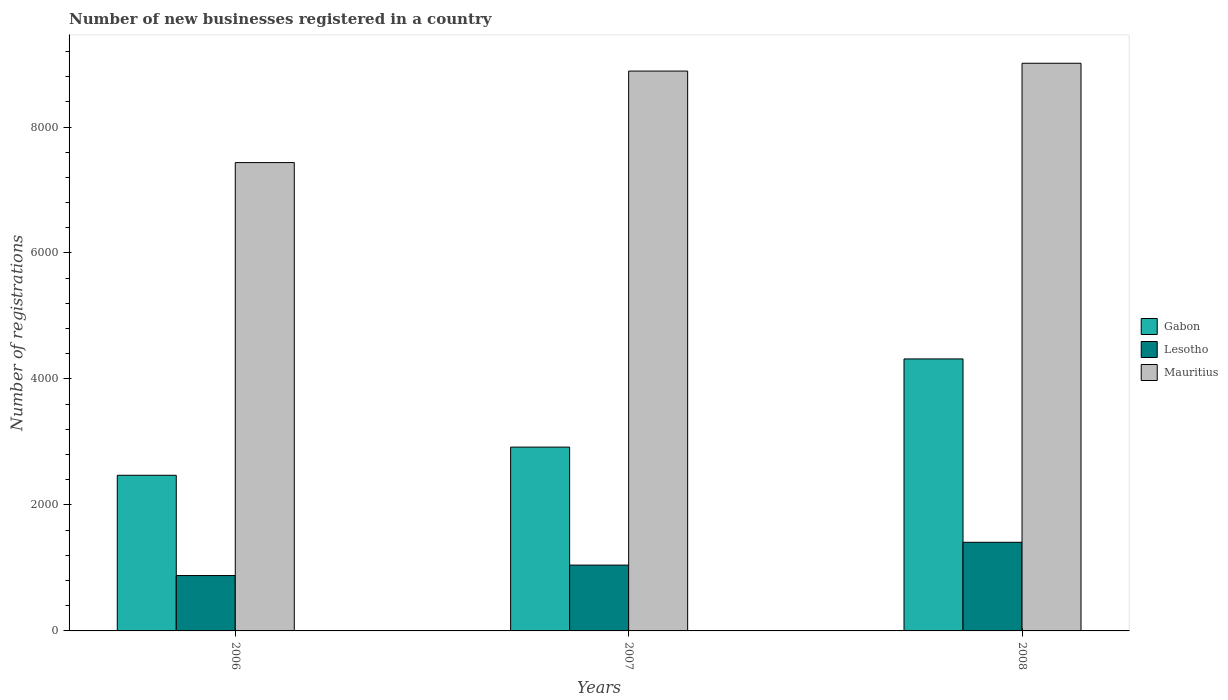How many groups of bars are there?
Keep it short and to the point. 3. How many bars are there on the 2nd tick from the left?
Offer a very short reply. 3. What is the label of the 2nd group of bars from the left?
Your answer should be very brief. 2007. What is the number of new businesses registered in Lesotho in 2008?
Your answer should be compact. 1407. Across all years, what is the maximum number of new businesses registered in Gabon?
Make the answer very short. 4318. Across all years, what is the minimum number of new businesses registered in Gabon?
Provide a short and direct response. 2471. In which year was the number of new businesses registered in Mauritius maximum?
Ensure brevity in your answer.  2008. In which year was the number of new businesses registered in Gabon minimum?
Ensure brevity in your answer.  2006. What is the total number of new businesses registered in Lesotho in the graph?
Offer a very short reply. 3331. What is the difference between the number of new businesses registered in Gabon in 2007 and that in 2008?
Offer a very short reply. -1400. What is the difference between the number of new businesses registered in Gabon in 2007 and the number of new businesses registered in Mauritius in 2008?
Your answer should be compact. -6094. What is the average number of new businesses registered in Gabon per year?
Your response must be concise. 3235.67. In the year 2007, what is the difference between the number of new businesses registered in Gabon and number of new businesses registered in Mauritius?
Keep it short and to the point. -5970. What is the ratio of the number of new businesses registered in Mauritius in 2006 to that in 2008?
Offer a very short reply. 0.83. What is the difference between the highest and the second highest number of new businesses registered in Mauritius?
Offer a terse response. 124. What is the difference between the highest and the lowest number of new businesses registered in Lesotho?
Give a very brief answer. 528. What does the 2nd bar from the left in 2008 represents?
Your response must be concise. Lesotho. What does the 2nd bar from the right in 2008 represents?
Provide a succinct answer. Lesotho. Is it the case that in every year, the sum of the number of new businesses registered in Lesotho and number of new businesses registered in Mauritius is greater than the number of new businesses registered in Gabon?
Your answer should be compact. Yes. Are the values on the major ticks of Y-axis written in scientific E-notation?
Make the answer very short. No. Does the graph contain any zero values?
Ensure brevity in your answer.  No. Does the graph contain grids?
Your answer should be compact. No. Where does the legend appear in the graph?
Offer a terse response. Center right. How are the legend labels stacked?
Keep it short and to the point. Vertical. What is the title of the graph?
Your answer should be compact. Number of new businesses registered in a country. Does "Vanuatu" appear as one of the legend labels in the graph?
Offer a very short reply. No. What is the label or title of the X-axis?
Provide a short and direct response. Years. What is the label or title of the Y-axis?
Ensure brevity in your answer.  Number of registrations. What is the Number of registrations in Gabon in 2006?
Make the answer very short. 2471. What is the Number of registrations in Lesotho in 2006?
Keep it short and to the point. 879. What is the Number of registrations of Mauritius in 2006?
Ensure brevity in your answer.  7435. What is the Number of registrations of Gabon in 2007?
Ensure brevity in your answer.  2918. What is the Number of registrations in Lesotho in 2007?
Your response must be concise. 1045. What is the Number of registrations of Mauritius in 2007?
Make the answer very short. 8888. What is the Number of registrations of Gabon in 2008?
Provide a succinct answer. 4318. What is the Number of registrations of Lesotho in 2008?
Give a very brief answer. 1407. What is the Number of registrations of Mauritius in 2008?
Your response must be concise. 9012. Across all years, what is the maximum Number of registrations of Gabon?
Ensure brevity in your answer.  4318. Across all years, what is the maximum Number of registrations of Lesotho?
Provide a short and direct response. 1407. Across all years, what is the maximum Number of registrations in Mauritius?
Your answer should be very brief. 9012. Across all years, what is the minimum Number of registrations of Gabon?
Ensure brevity in your answer.  2471. Across all years, what is the minimum Number of registrations in Lesotho?
Keep it short and to the point. 879. Across all years, what is the minimum Number of registrations of Mauritius?
Offer a terse response. 7435. What is the total Number of registrations of Gabon in the graph?
Offer a very short reply. 9707. What is the total Number of registrations in Lesotho in the graph?
Offer a terse response. 3331. What is the total Number of registrations in Mauritius in the graph?
Offer a terse response. 2.53e+04. What is the difference between the Number of registrations of Gabon in 2006 and that in 2007?
Offer a very short reply. -447. What is the difference between the Number of registrations in Lesotho in 2006 and that in 2007?
Give a very brief answer. -166. What is the difference between the Number of registrations in Mauritius in 2006 and that in 2007?
Offer a terse response. -1453. What is the difference between the Number of registrations in Gabon in 2006 and that in 2008?
Keep it short and to the point. -1847. What is the difference between the Number of registrations in Lesotho in 2006 and that in 2008?
Give a very brief answer. -528. What is the difference between the Number of registrations in Mauritius in 2006 and that in 2008?
Provide a short and direct response. -1577. What is the difference between the Number of registrations of Gabon in 2007 and that in 2008?
Keep it short and to the point. -1400. What is the difference between the Number of registrations in Lesotho in 2007 and that in 2008?
Offer a terse response. -362. What is the difference between the Number of registrations of Mauritius in 2007 and that in 2008?
Ensure brevity in your answer.  -124. What is the difference between the Number of registrations in Gabon in 2006 and the Number of registrations in Lesotho in 2007?
Offer a very short reply. 1426. What is the difference between the Number of registrations of Gabon in 2006 and the Number of registrations of Mauritius in 2007?
Make the answer very short. -6417. What is the difference between the Number of registrations in Lesotho in 2006 and the Number of registrations in Mauritius in 2007?
Your response must be concise. -8009. What is the difference between the Number of registrations in Gabon in 2006 and the Number of registrations in Lesotho in 2008?
Offer a very short reply. 1064. What is the difference between the Number of registrations of Gabon in 2006 and the Number of registrations of Mauritius in 2008?
Ensure brevity in your answer.  -6541. What is the difference between the Number of registrations of Lesotho in 2006 and the Number of registrations of Mauritius in 2008?
Make the answer very short. -8133. What is the difference between the Number of registrations of Gabon in 2007 and the Number of registrations of Lesotho in 2008?
Provide a succinct answer. 1511. What is the difference between the Number of registrations of Gabon in 2007 and the Number of registrations of Mauritius in 2008?
Make the answer very short. -6094. What is the difference between the Number of registrations in Lesotho in 2007 and the Number of registrations in Mauritius in 2008?
Provide a short and direct response. -7967. What is the average Number of registrations in Gabon per year?
Provide a short and direct response. 3235.67. What is the average Number of registrations of Lesotho per year?
Give a very brief answer. 1110.33. What is the average Number of registrations in Mauritius per year?
Provide a short and direct response. 8445. In the year 2006, what is the difference between the Number of registrations in Gabon and Number of registrations in Lesotho?
Your answer should be compact. 1592. In the year 2006, what is the difference between the Number of registrations of Gabon and Number of registrations of Mauritius?
Provide a succinct answer. -4964. In the year 2006, what is the difference between the Number of registrations in Lesotho and Number of registrations in Mauritius?
Your response must be concise. -6556. In the year 2007, what is the difference between the Number of registrations of Gabon and Number of registrations of Lesotho?
Keep it short and to the point. 1873. In the year 2007, what is the difference between the Number of registrations in Gabon and Number of registrations in Mauritius?
Your answer should be very brief. -5970. In the year 2007, what is the difference between the Number of registrations of Lesotho and Number of registrations of Mauritius?
Give a very brief answer. -7843. In the year 2008, what is the difference between the Number of registrations of Gabon and Number of registrations of Lesotho?
Your answer should be compact. 2911. In the year 2008, what is the difference between the Number of registrations in Gabon and Number of registrations in Mauritius?
Offer a very short reply. -4694. In the year 2008, what is the difference between the Number of registrations in Lesotho and Number of registrations in Mauritius?
Ensure brevity in your answer.  -7605. What is the ratio of the Number of registrations in Gabon in 2006 to that in 2007?
Make the answer very short. 0.85. What is the ratio of the Number of registrations of Lesotho in 2006 to that in 2007?
Ensure brevity in your answer.  0.84. What is the ratio of the Number of registrations in Mauritius in 2006 to that in 2007?
Your response must be concise. 0.84. What is the ratio of the Number of registrations in Gabon in 2006 to that in 2008?
Offer a very short reply. 0.57. What is the ratio of the Number of registrations in Lesotho in 2006 to that in 2008?
Make the answer very short. 0.62. What is the ratio of the Number of registrations in Mauritius in 2006 to that in 2008?
Offer a very short reply. 0.82. What is the ratio of the Number of registrations in Gabon in 2007 to that in 2008?
Provide a short and direct response. 0.68. What is the ratio of the Number of registrations of Lesotho in 2007 to that in 2008?
Ensure brevity in your answer.  0.74. What is the ratio of the Number of registrations in Mauritius in 2007 to that in 2008?
Make the answer very short. 0.99. What is the difference between the highest and the second highest Number of registrations in Gabon?
Provide a short and direct response. 1400. What is the difference between the highest and the second highest Number of registrations of Lesotho?
Make the answer very short. 362. What is the difference between the highest and the second highest Number of registrations of Mauritius?
Offer a very short reply. 124. What is the difference between the highest and the lowest Number of registrations in Gabon?
Your answer should be very brief. 1847. What is the difference between the highest and the lowest Number of registrations of Lesotho?
Give a very brief answer. 528. What is the difference between the highest and the lowest Number of registrations of Mauritius?
Your answer should be compact. 1577. 